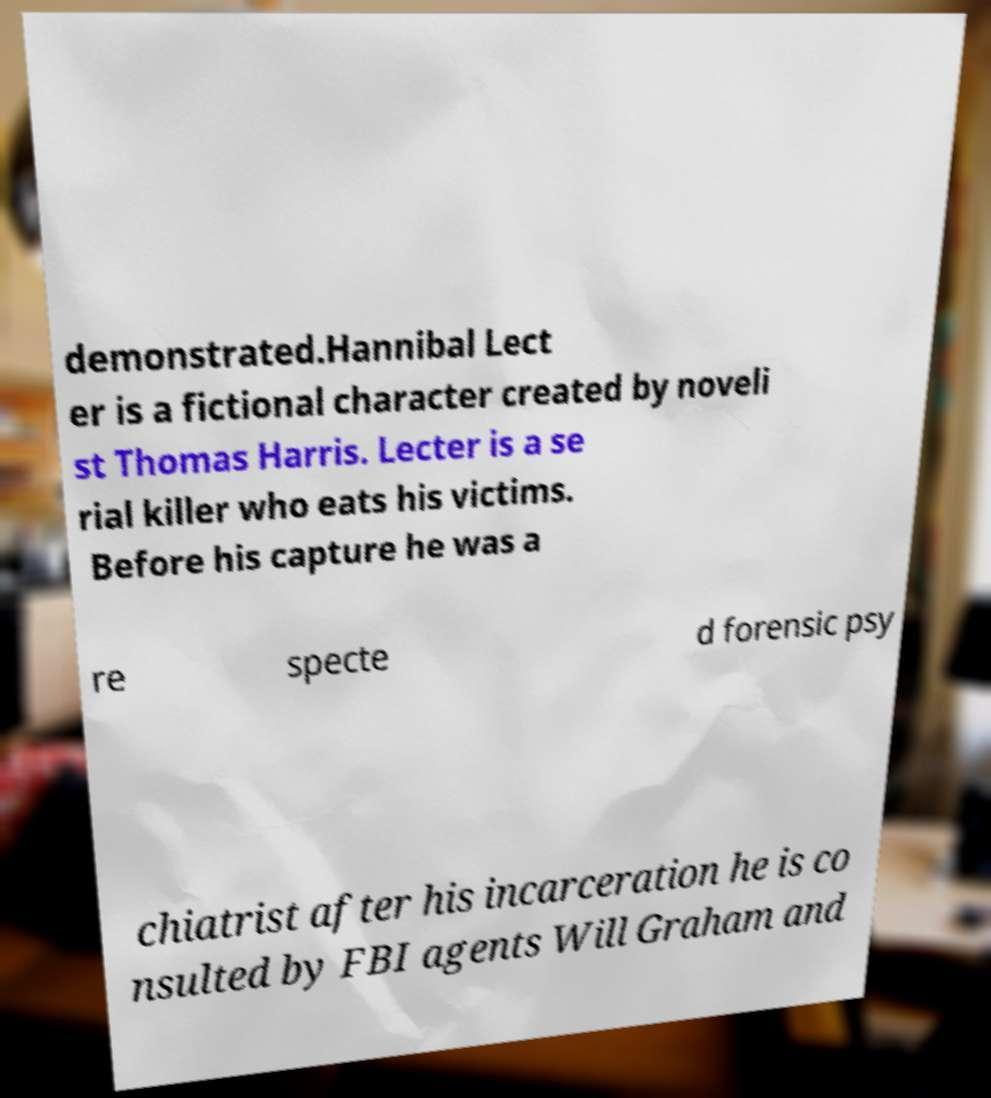I need the written content from this picture converted into text. Can you do that? demonstrated.Hannibal Lect er is a fictional character created by noveli st Thomas Harris. Lecter is a se rial killer who eats his victims. Before his capture he was a re specte d forensic psy chiatrist after his incarceration he is co nsulted by FBI agents Will Graham and 